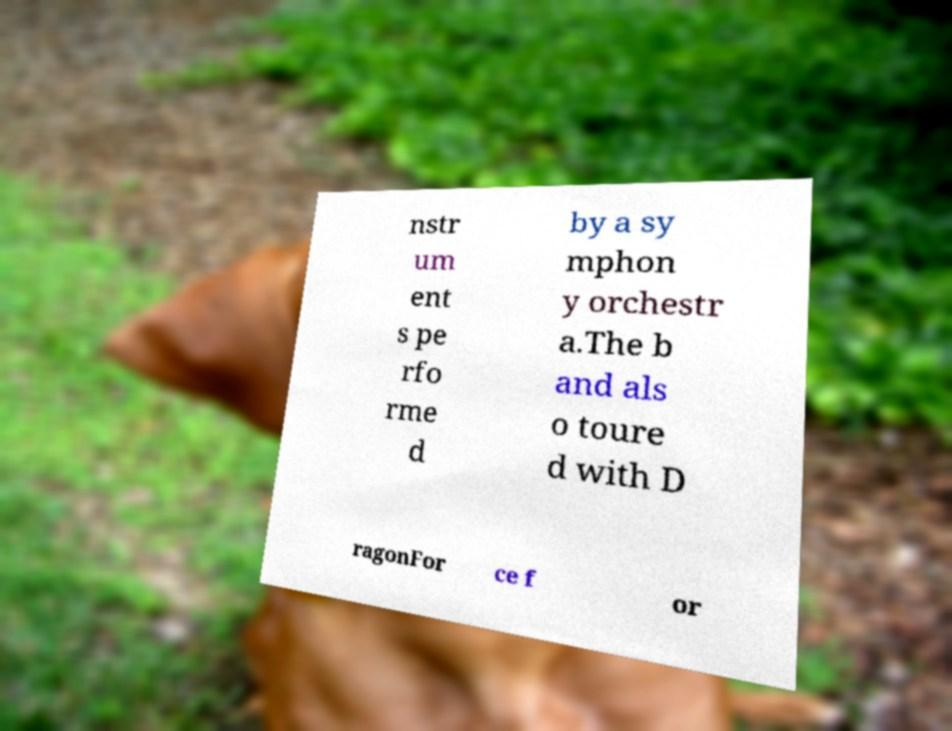For documentation purposes, I need the text within this image transcribed. Could you provide that? nstr um ent s pe rfo rme d by a sy mphon y orchestr a.The b and als o toure d with D ragonFor ce f or 